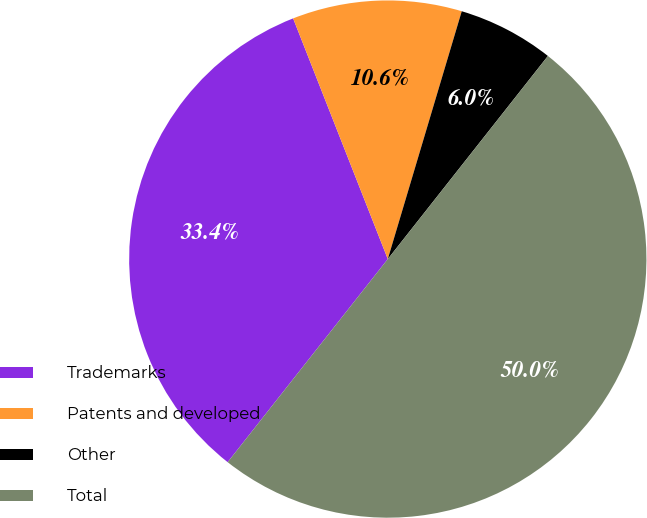Convert chart to OTSL. <chart><loc_0><loc_0><loc_500><loc_500><pie_chart><fcel>Trademarks<fcel>Patents and developed<fcel>Other<fcel>Total<nl><fcel>33.41%<fcel>10.58%<fcel>6.01%<fcel>50.0%<nl></chart> 